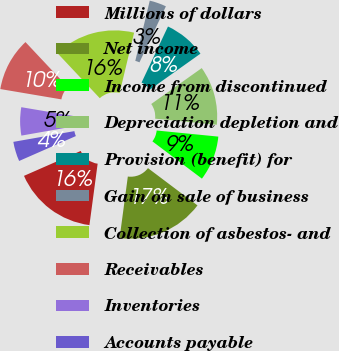Convert chart. <chart><loc_0><loc_0><loc_500><loc_500><pie_chart><fcel>Millions of dollars<fcel>Net income<fcel>Income from discontinued<fcel>Depreciation depletion and<fcel>Provision (benefit) for<fcel>Gain on sale of business<fcel>Collection of asbestos- and<fcel>Receivables<fcel>Inventories<fcel>Accounts payable<nl><fcel>16.3%<fcel>16.85%<fcel>8.7%<fcel>11.41%<fcel>8.15%<fcel>3.26%<fcel>15.76%<fcel>10.33%<fcel>5.44%<fcel>3.81%<nl></chart> 